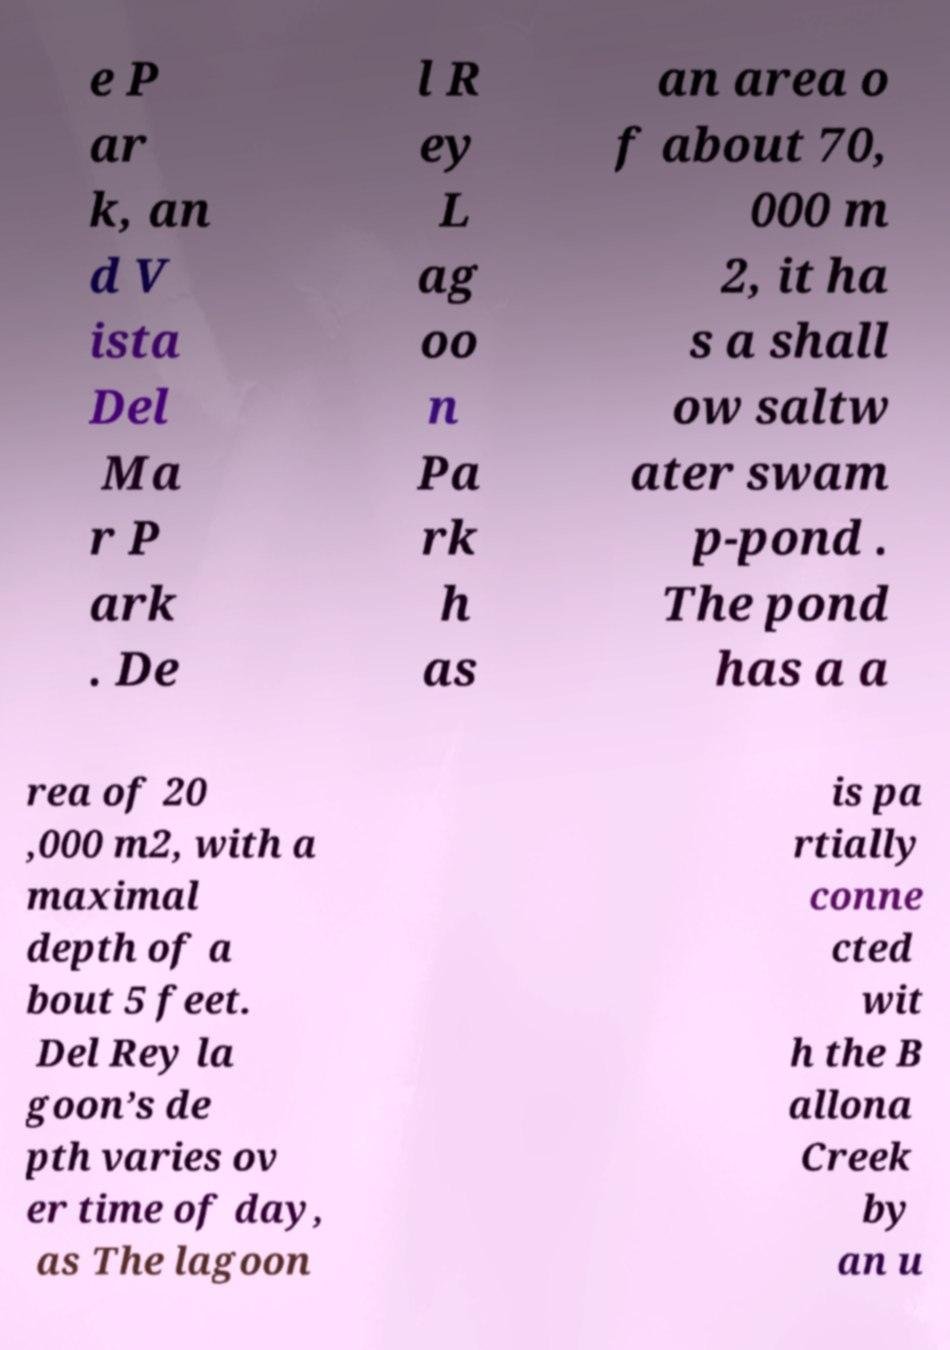Please read and relay the text visible in this image. What does it say? e P ar k, an d V ista Del Ma r P ark . De l R ey L ag oo n Pa rk h as an area o f about 70, 000 m 2, it ha s a shall ow saltw ater swam p-pond . The pond has a a rea of 20 ,000 m2, with a maximal depth of a bout 5 feet. Del Rey la goon’s de pth varies ov er time of day, as The lagoon is pa rtially conne cted wit h the B allona Creek by an u 